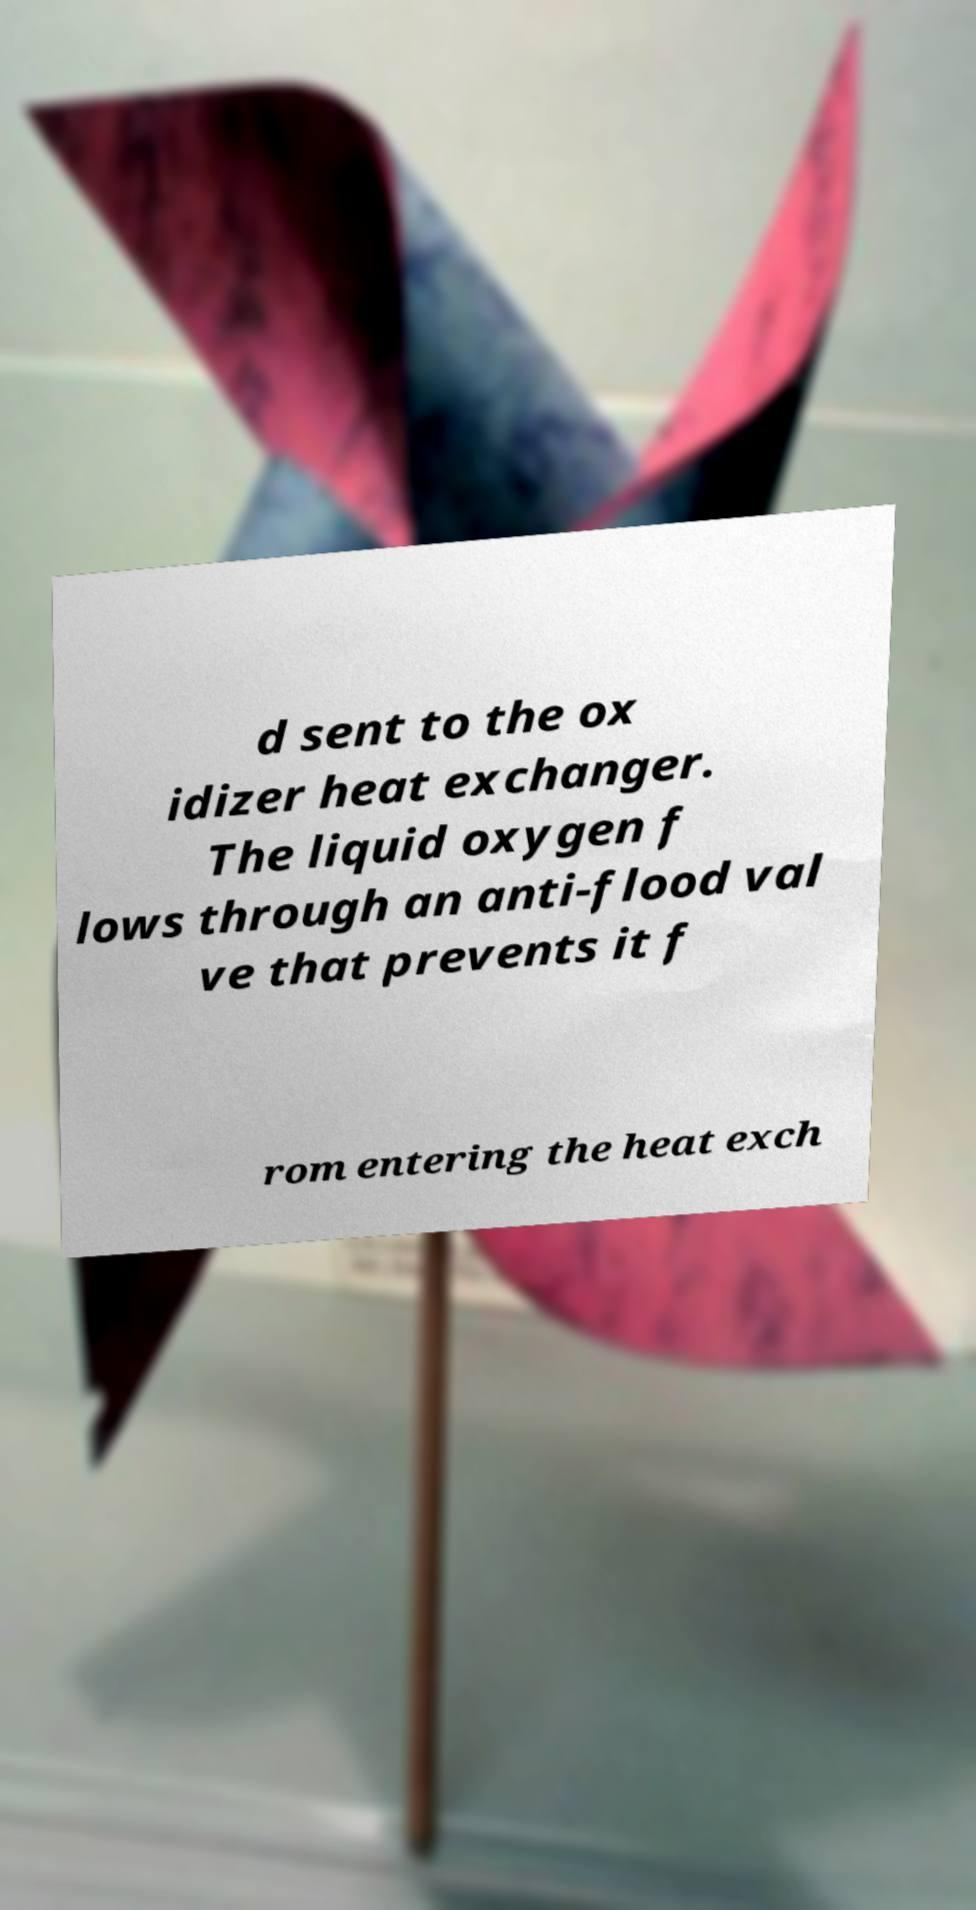I need the written content from this picture converted into text. Can you do that? d sent to the ox idizer heat exchanger. The liquid oxygen f lows through an anti-flood val ve that prevents it f rom entering the heat exch 